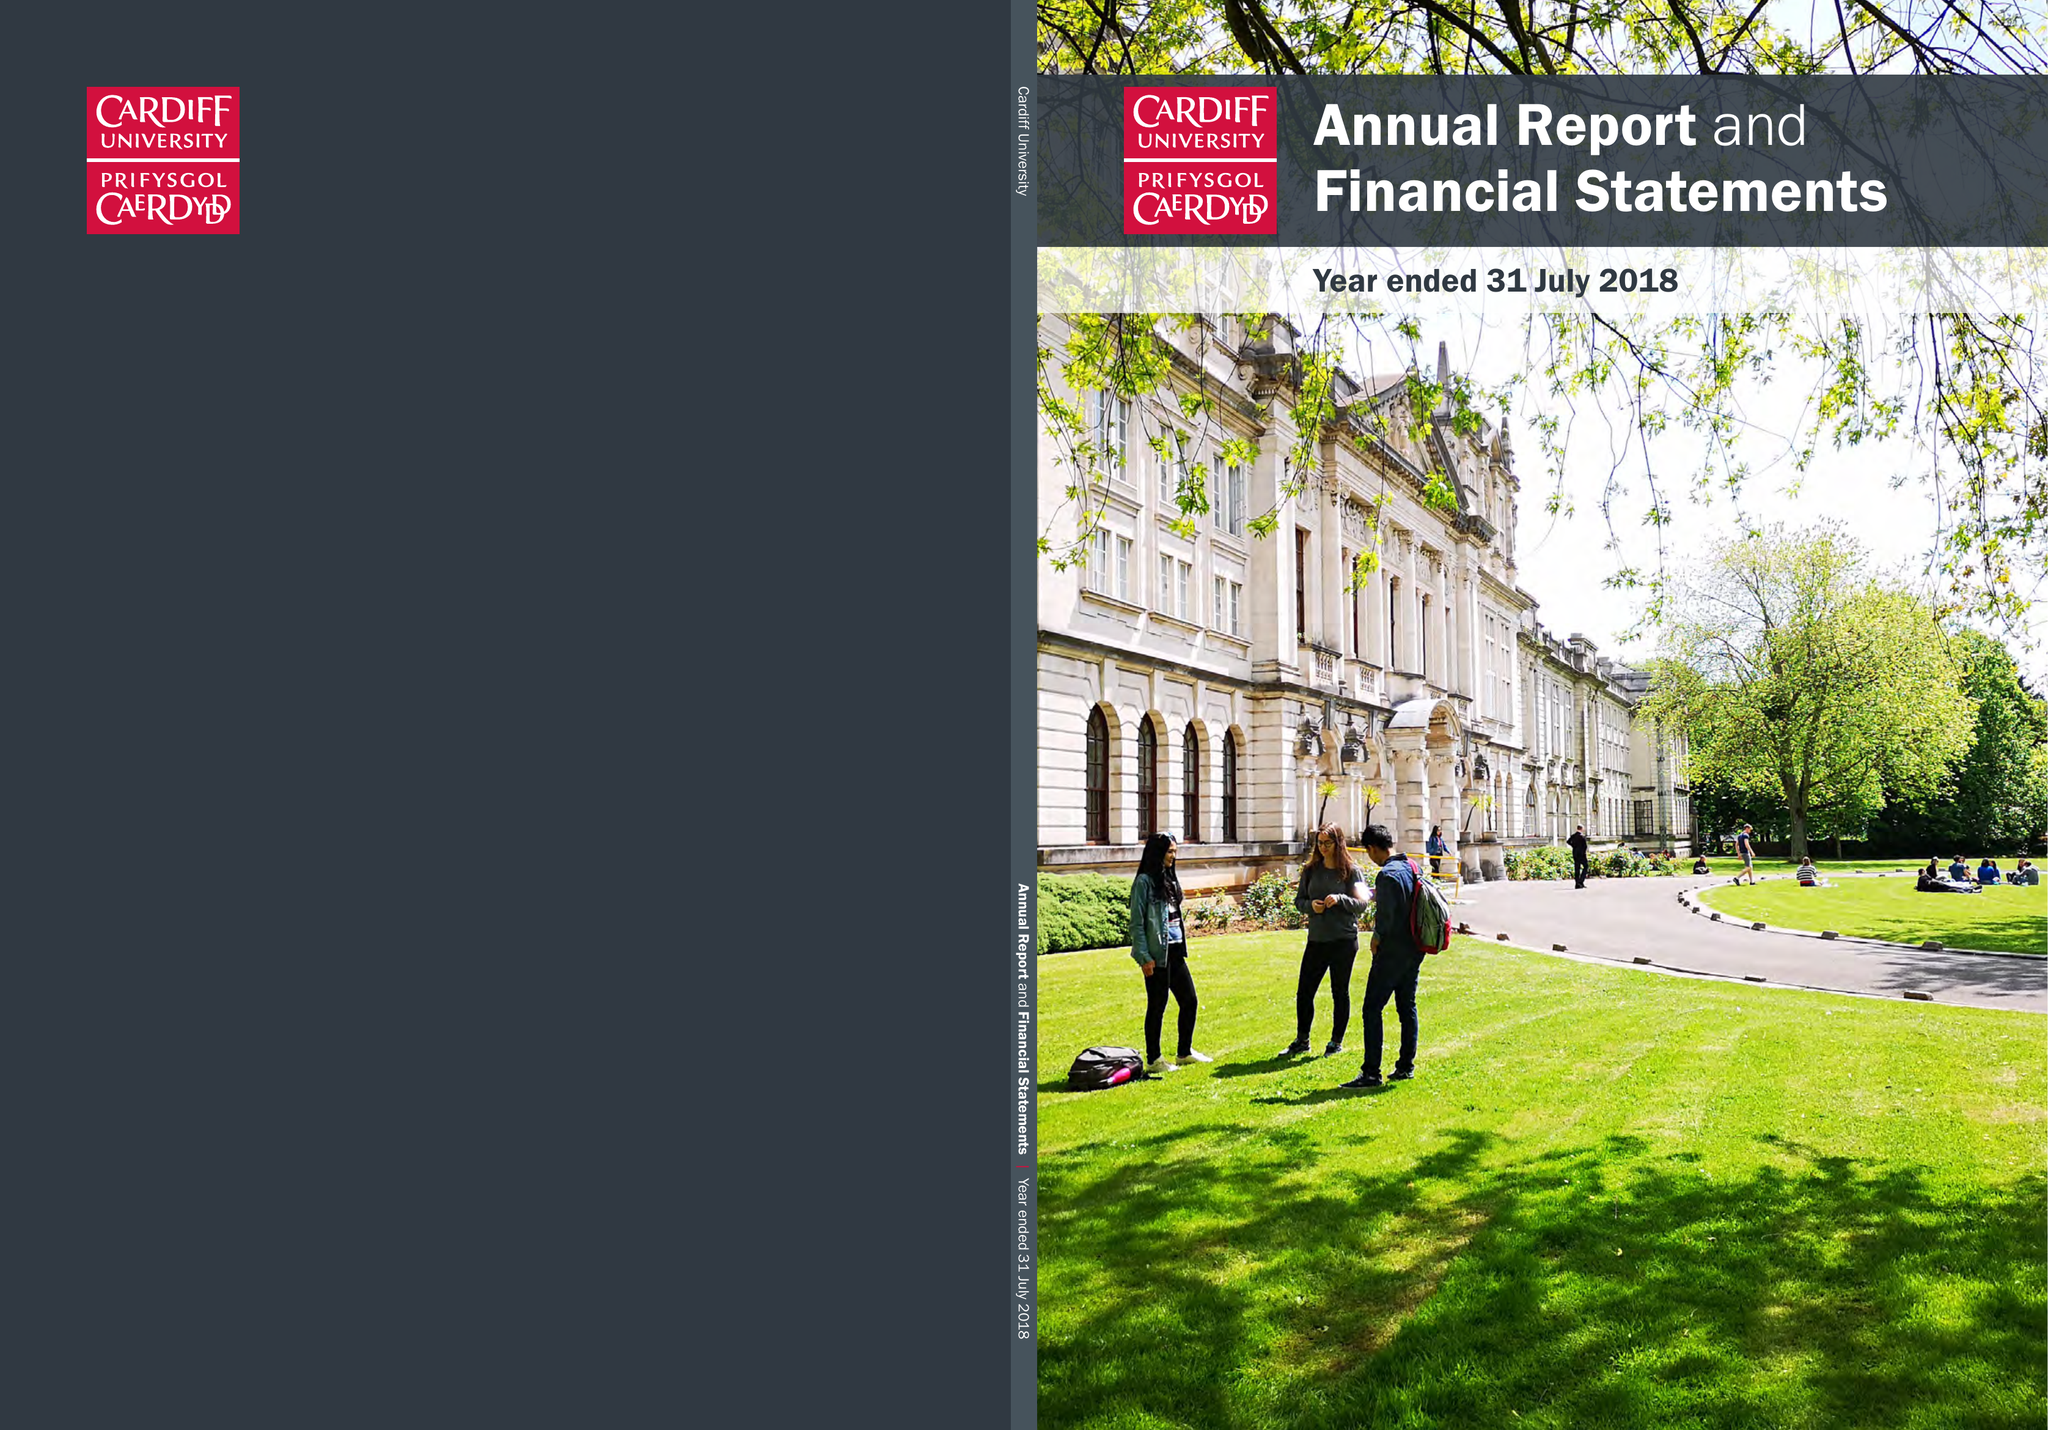What is the value for the income_annually_in_british_pounds?
Answer the question using a single word or phrase. 517689000.00 